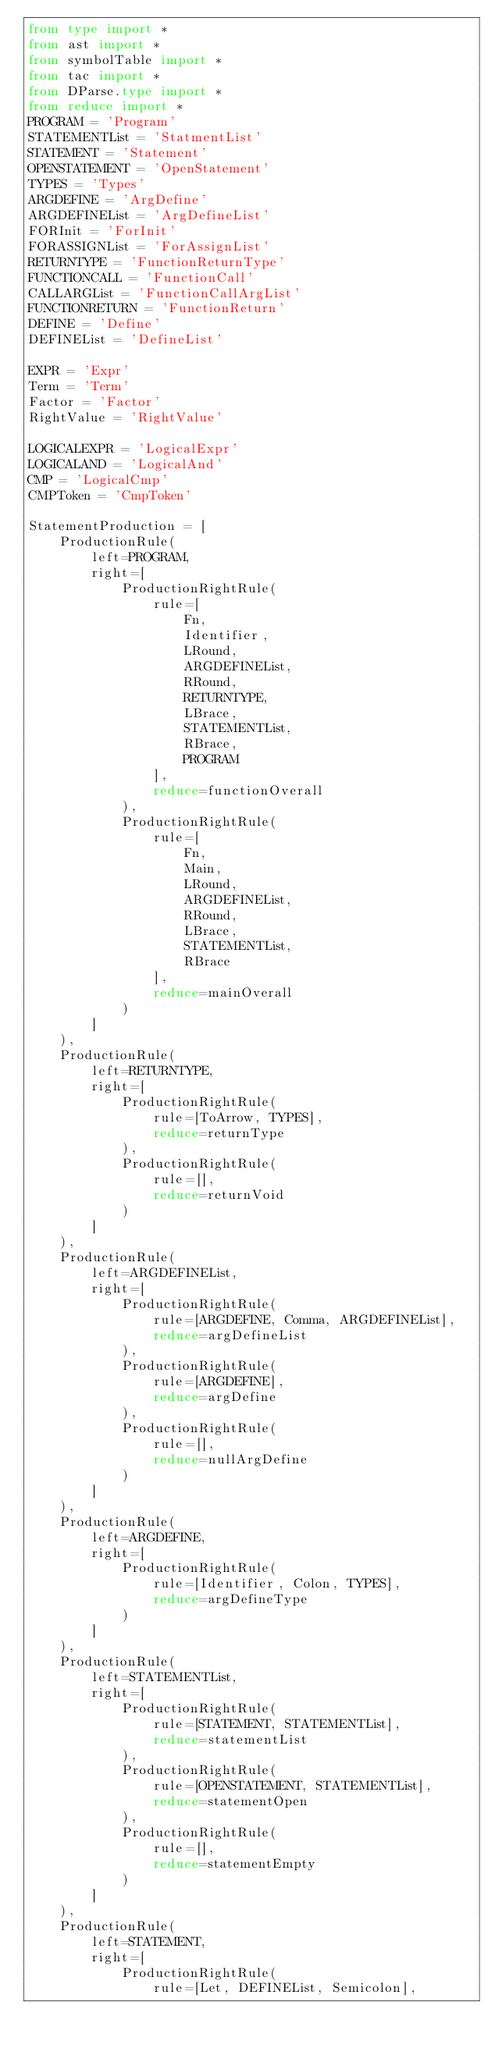<code> <loc_0><loc_0><loc_500><loc_500><_Python_>from type import *
from ast import *
from symbolTable import *
from tac import *
from DParse.type import *
from reduce import *
PROGRAM = 'Program'
STATEMENTList = 'StatmentList'
STATEMENT = 'Statement'
OPENSTATEMENT = 'OpenStatement'
TYPES = 'Types'
ARGDEFINE = 'ArgDefine'
ARGDEFINEList = 'ArgDefineList'
FORInit = 'ForInit'
FORASSIGNList = 'ForAssignList'
RETURNTYPE = 'FunctionReturnType'
FUNCTIONCALL = 'FunctionCall'
CALLARGList = 'FunctionCallArgList'
FUNCTIONRETURN = 'FunctionReturn'
DEFINE = 'Define'
DEFINEList = 'DefineList'

EXPR = 'Expr'
Term = 'Term'
Factor = 'Factor'
RightValue = 'RightValue'

LOGICALEXPR = 'LogicalExpr'
LOGICALAND = 'LogicalAnd'
CMP = 'LogicalCmp'
CMPToken = 'CmpToken'

StatementProduction = [
    ProductionRule(
        left=PROGRAM,
        right=[
            ProductionRightRule(
                rule=[
                    Fn,
                    Identifier,
                    LRound,
                    ARGDEFINEList,
                    RRound,
                    RETURNTYPE,
                    LBrace,
                    STATEMENTList,
                    RBrace,
                    PROGRAM
                ],
                reduce=functionOverall
            ),
            ProductionRightRule(
                rule=[
                    Fn,
                    Main,
                    LRound,
                    ARGDEFINEList,
                    RRound,
                    LBrace,
                    STATEMENTList,
                    RBrace
                ],
                reduce=mainOverall
            )
        ]
    ),
    ProductionRule(
        left=RETURNTYPE,
        right=[
            ProductionRightRule(
                rule=[ToArrow, TYPES],
                reduce=returnType
            ),
            ProductionRightRule(
                rule=[],
                reduce=returnVoid
            )
        ]
    ),
    ProductionRule(
        left=ARGDEFINEList,
        right=[
            ProductionRightRule(
                rule=[ARGDEFINE, Comma, ARGDEFINEList],
                reduce=argDefineList
            ),
            ProductionRightRule(
                rule=[ARGDEFINE],
                reduce=argDefine
            ),
            ProductionRightRule(
                rule=[],
                reduce=nullArgDefine
            )
        ]
    ),
    ProductionRule(
        left=ARGDEFINE,
        right=[
            ProductionRightRule(
                rule=[Identifier, Colon, TYPES],
                reduce=argDefineType
            )
        ]
    ),
    ProductionRule(
        left=STATEMENTList,
        right=[
            ProductionRightRule(
                rule=[STATEMENT, STATEMENTList],
                reduce=statementList
            ),
            ProductionRightRule(
                rule=[OPENSTATEMENT, STATEMENTList],
                reduce=statementOpen
            ),
            ProductionRightRule(
                rule=[],
                reduce=statementEmpty
            )
        ]
    ),
    ProductionRule(
        left=STATEMENT,
        right=[
            ProductionRightRule(
                rule=[Let, DEFINEList, Semicolon],</code> 